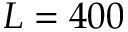<formula> <loc_0><loc_0><loc_500><loc_500>L = 4 0 0</formula> 